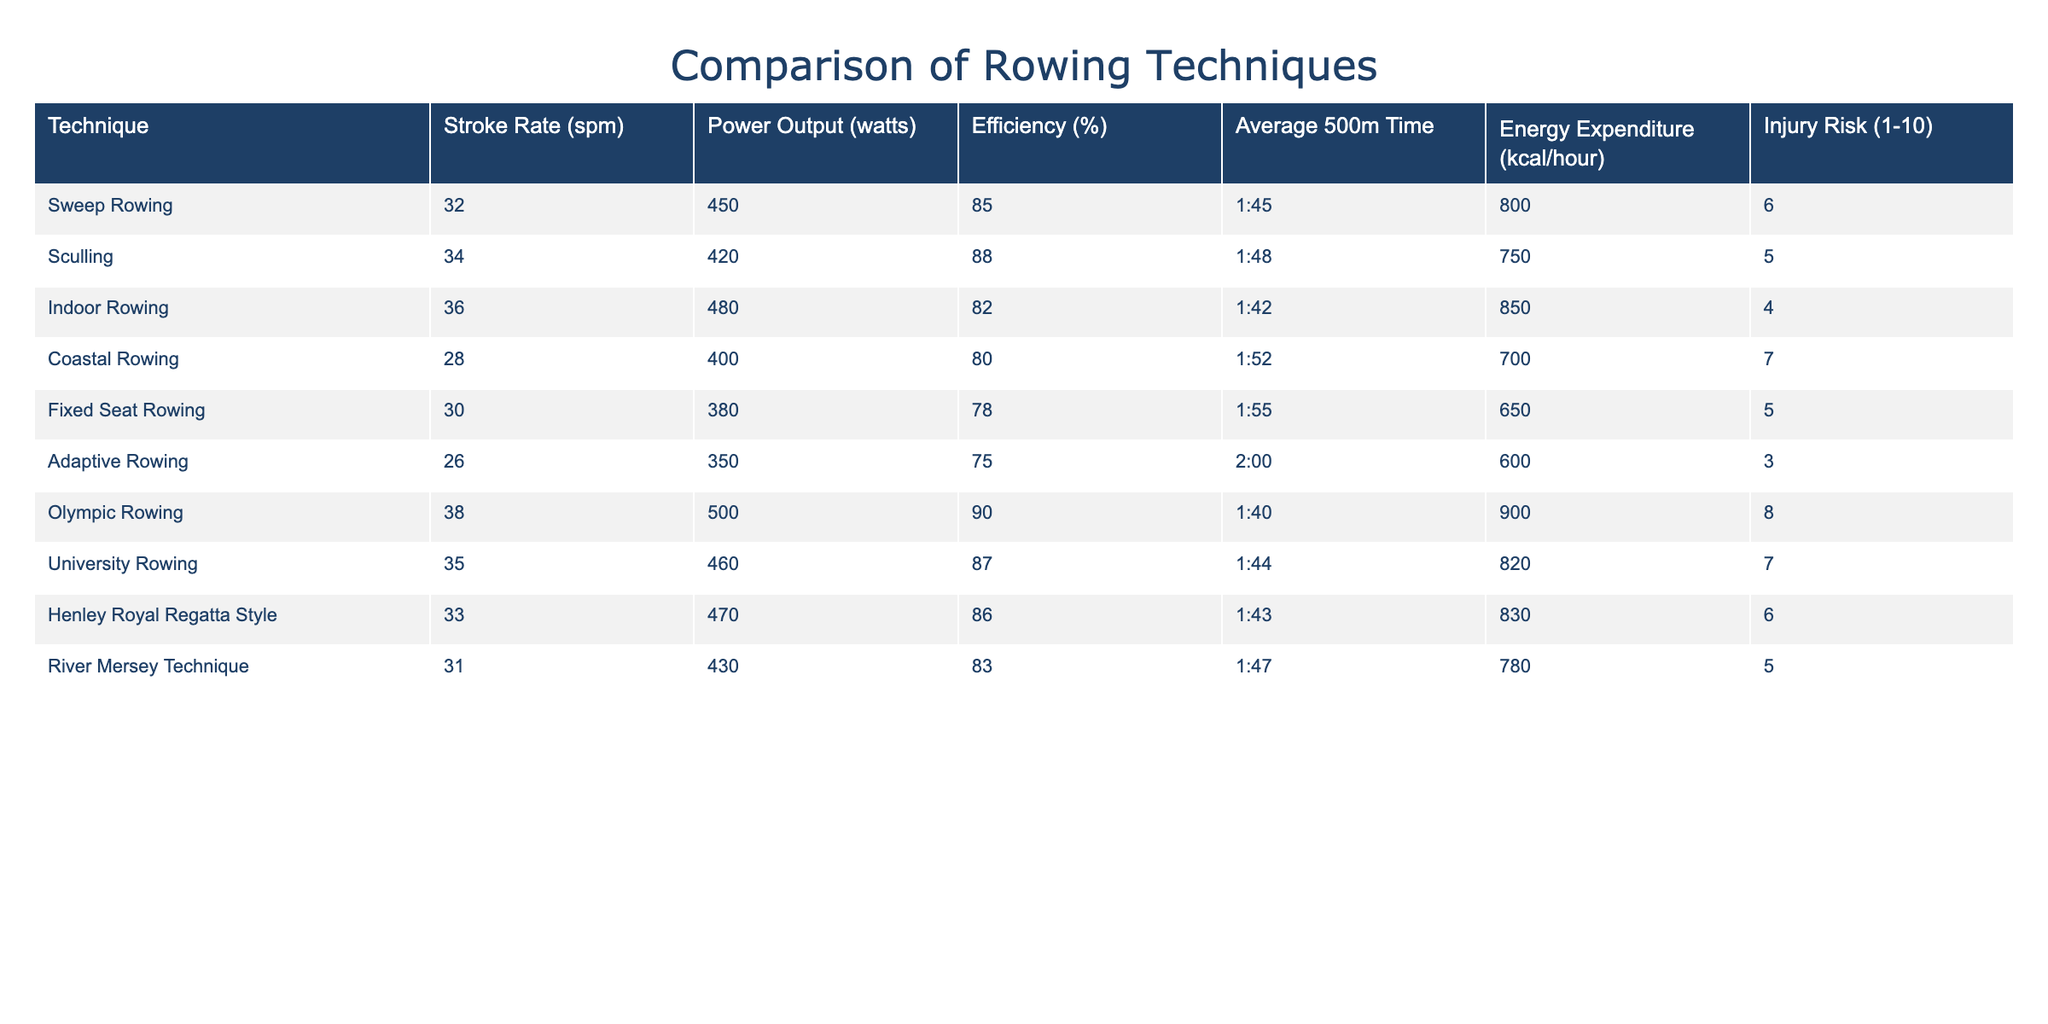What's the stroke rate of Coastal Rowing? The stroke rate is listed in the table under the "Stroke Rate (spm)" column for Coastal Rowing. The corresponding value is 28.
Answer: 28 Which rowing technique has the highest power output? To find the highest power output, we compare the values in the "Power Output (watts)" column. The highest value is 500, which corresponds to Olympic Rowing.
Answer: Olympic Rowing What is the average energy expenditure of the different rowing techniques? We sum up the energy expenditure values from the "Energy Expenditure (kcal/hour)" column: 800 + 750 + 850 + 700 + 650 + 600 + 900 + 820 + 830 + 780 = 8,030. There are 10 rows, so the average is 8,030 / 10 = 803.
Answer: 803 Is the efficiency of Adaptive Rowing greater than 75%? In the table, the efficiency for Adaptive Rowing is listed as 75%. Since the question asks for greater than 75%, the answer is no.
Answer: No Which rowing technique has the lowest injury risk and what is the value? We check the "Injury Risk (1-10)" column and find that Adaptive Rowing has the lowest value of 3.
Answer: Adaptive Rowing, 3 What is the difference in average 500m time between Sweep Rowing and Sculling? The average 500m time for Sweep Rowing is 1:45 and for Sculling, it is 1:48. To find the difference, we need to convert these times into seconds: 1:45 = 105 seconds and 1:48 = 108 seconds. The difference is 108 - 105 = 3 seconds.
Answer: 3 seconds Which technique has both a higher stroke rate and efficiency than the River Mersey Technique? First, we check River Mersey Technique's "Stroke Rate (spm)" which is 31 and "Efficiency (%)" which is 83. Then we look for techniques that have a stroke rate greater than 31 (Sweep Rowing, Sculling, Indoor Rowing, Olympic Rowing, University Rowing, Henley Royal Regatta Style) and efficiency greater than 83 (Olympic Rowing). The only technique meeting both criteria is Olympic Rowing.
Answer: Olympic Rowing Is the average energy expenditure for Coastal Rowing higher than 700 kcal/hour? The energy expenditure value for Coastal Rowing in the table is 700 kcal/hour. The question asks if it's higher, and since it is not, the answer is no.
Answer: No What rowing technique has the best efficiency and what is that percentage? To find the best efficiency, we look at the "Efficiency (%)" column, where Olympic Rowing has the highest value of 90%.
Answer: Olympic Rowing, 90% 